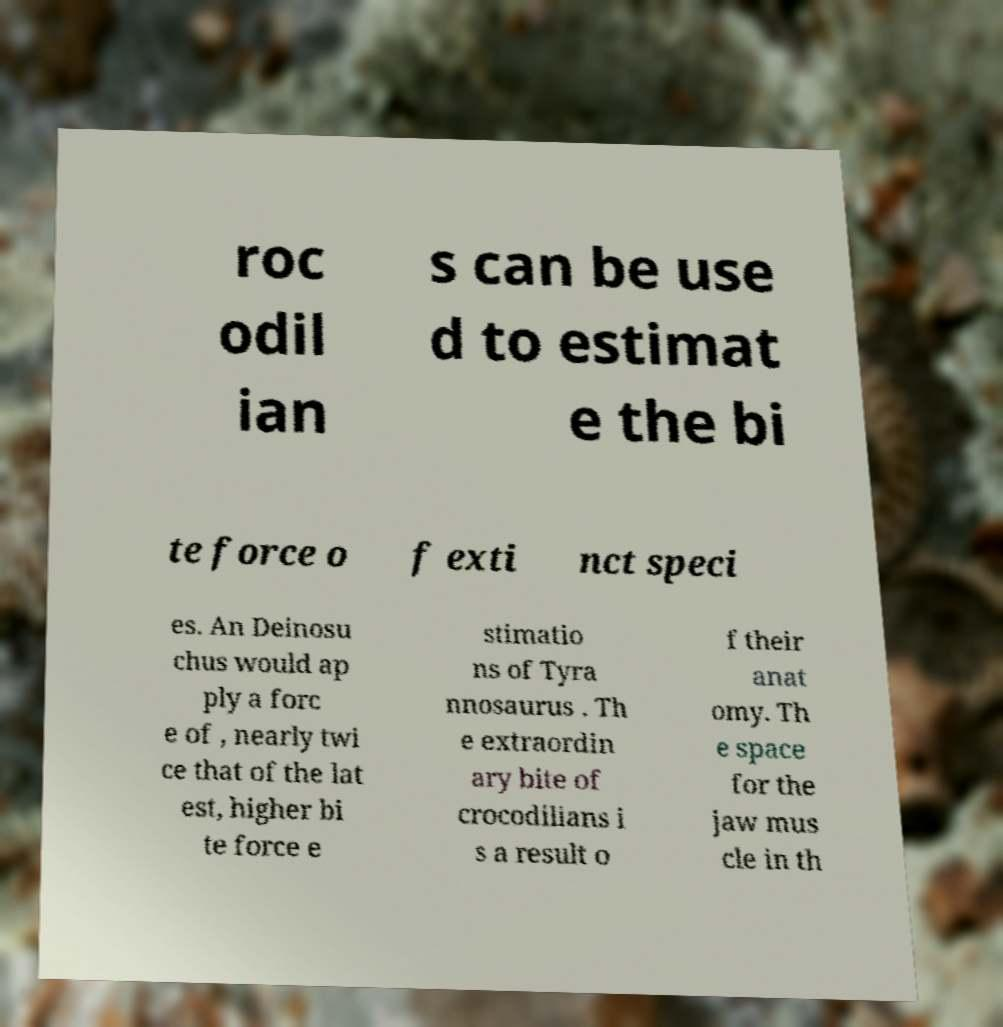Could you extract and type out the text from this image? roc odil ian s can be use d to estimat e the bi te force o f exti nct speci es. An Deinosu chus would ap ply a forc e of , nearly twi ce that of the lat est, higher bi te force e stimatio ns of Tyra nnosaurus . Th e extraordin ary bite of crocodilians i s a result o f their anat omy. Th e space for the jaw mus cle in th 